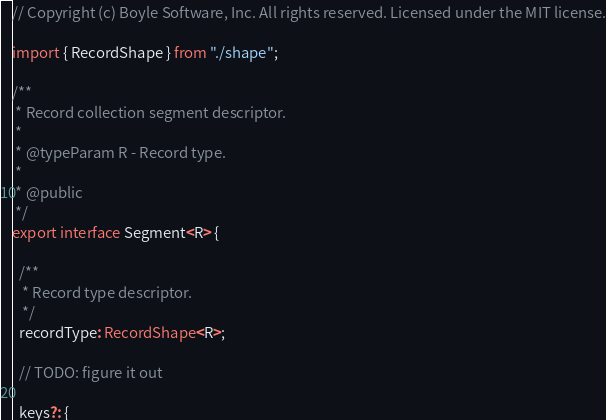Convert code to text. <code><loc_0><loc_0><loc_500><loc_500><_TypeScript_>// Copyright (c) Boyle Software, Inc. All rights reserved. Licensed under the MIT license.

import { RecordShape } from "./shape";

/**
 * Record collection segment descriptor.
 *
 * @typeParam R - Record type.
 *
 * @public
 */
export interface Segment<R> {

  /**
   * Record type descriptor.
   */
  recordType: RecordShape<R>;

  // TODO: figure it out

  keys?: {</code> 